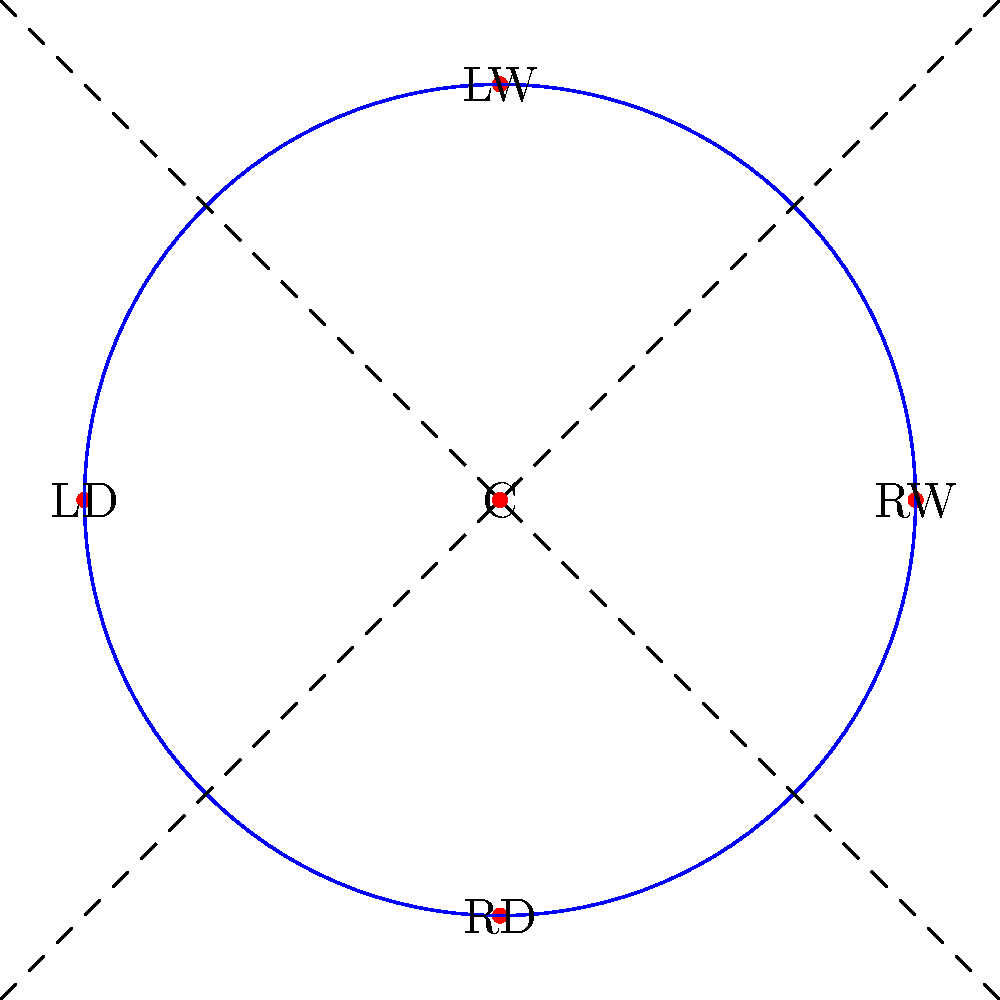Your child's hockey coach wants to implement a rotation system where players switch positions after each shift. The diagram shows the five positions on the ice: Center (C), Right Wing (RW), Left Wing (LW), Left Defense (LD), and Right Defense (RD). If the coach wants each player to experience all positions and return to their original position, what is the minimum number of rotations needed for a complete cycle? To solve this problem, we need to understand the concept of cyclic permutations in group theory. Let's approach this step-by-step:

1) First, we need to determine the order of rotation. Let's assume the rotation goes clockwise: C → RW → LW → LD → RD → C.

2) We can represent this rotation as a permutation: (C RW LW LD RD).

3) In group theory, the order of a permutation (the number of times it needs to be applied to return to the identity) is equal to the length of its longest cycle.

4) In this case, we have a single cycle of length 5.

5) Therefore, we need to apply this rotation 5 times for each player to experience all positions and return to their original position.

6) We can verify this:
   - After 1 rotation: (RD C RW LW LD)
   - After 2 rotations: (LD RD C RW LW)
   - After 3 rotations: (LW LD RD C RW)
   - After 4 rotations: (RW LW LD RD C)
   - After 5 rotations: (C RW LW LD RD) - back to the original configuration

Thus, the minimum number of rotations needed for a complete cycle is 5.
Answer: 5 rotations 